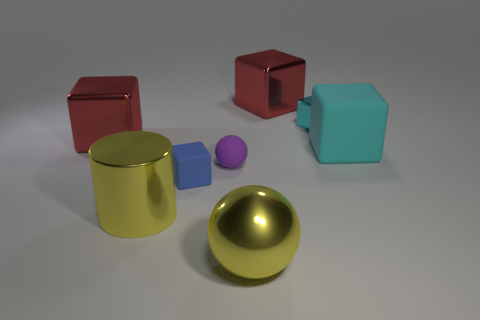Are there more large red shiny objects that are in front of the purple sphere than purple spheres?
Offer a very short reply. No. What number of metal things are both to the right of the blue matte object and in front of the cyan shiny thing?
Give a very brief answer. 1. What color is the small rubber object behind the block in front of the cyan rubber object?
Keep it short and to the point. Purple. What number of small cubes are the same color as the small metallic thing?
Your answer should be very brief. 0. Does the matte sphere have the same color as the small object that is right of the rubber sphere?
Your answer should be compact. No. Is the number of purple rubber objects less than the number of tiny matte objects?
Give a very brief answer. Yes. Is the number of small cyan blocks that are left of the blue rubber block greater than the number of blue objects right of the cyan matte thing?
Give a very brief answer. No. Are the large ball and the small blue block made of the same material?
Your answer should be compact. No. There is a tiny object that is on the right side of the purple matte ball; what number of large cylinders are in front of it?
Your answer should be compact. 1. Does the large shiny object in front of the cylinder have the same color as the big shiny cylinder?
Make the answer very short. Yes. 